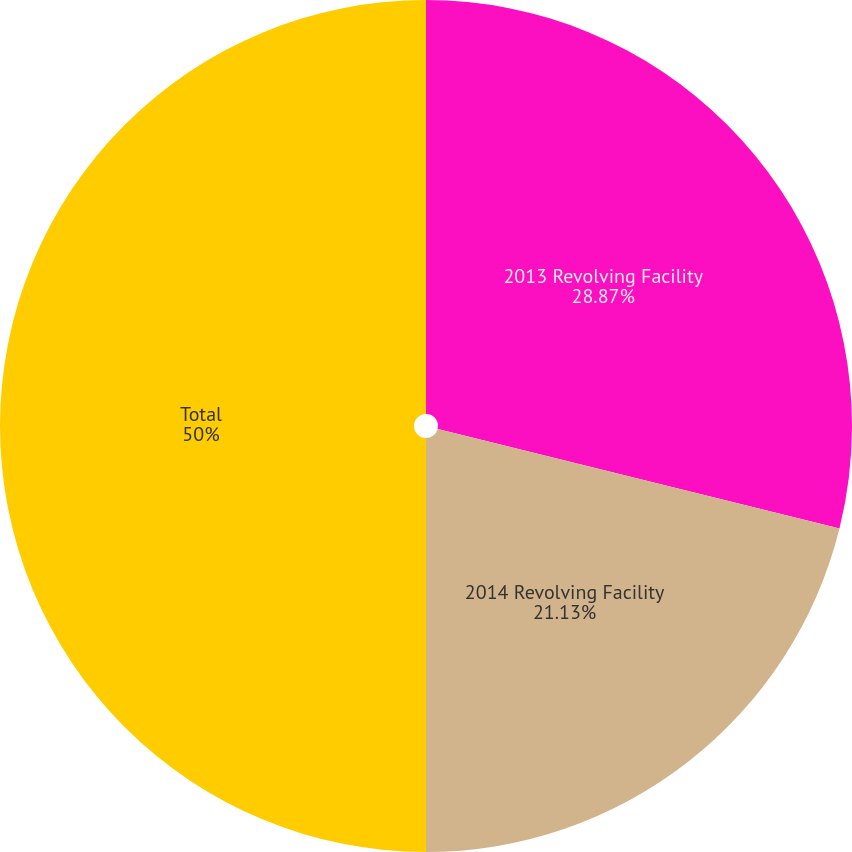Convert chart. <chart><loc_0><loc_0><loc_500><loc_500><pie_chart><fcel>2013 Revolving Facility<fcel>2014 Revolving Facility<fcel>Total<nl><fcel>28.87%<fcel>21.13%<fcel>50.0%<nl></chart> 